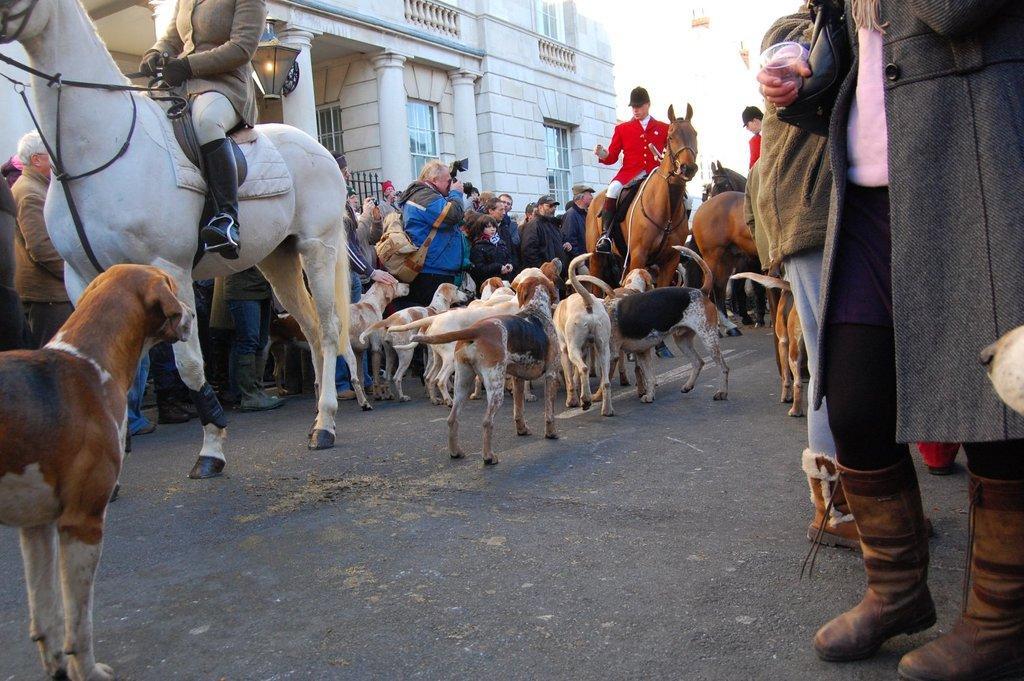How would you summarize this image in a sentence or two? In this image there are a few people sitting on the horses, there are few dogs and few people on the road in which some of them are taking photos with the cameras and a building. 